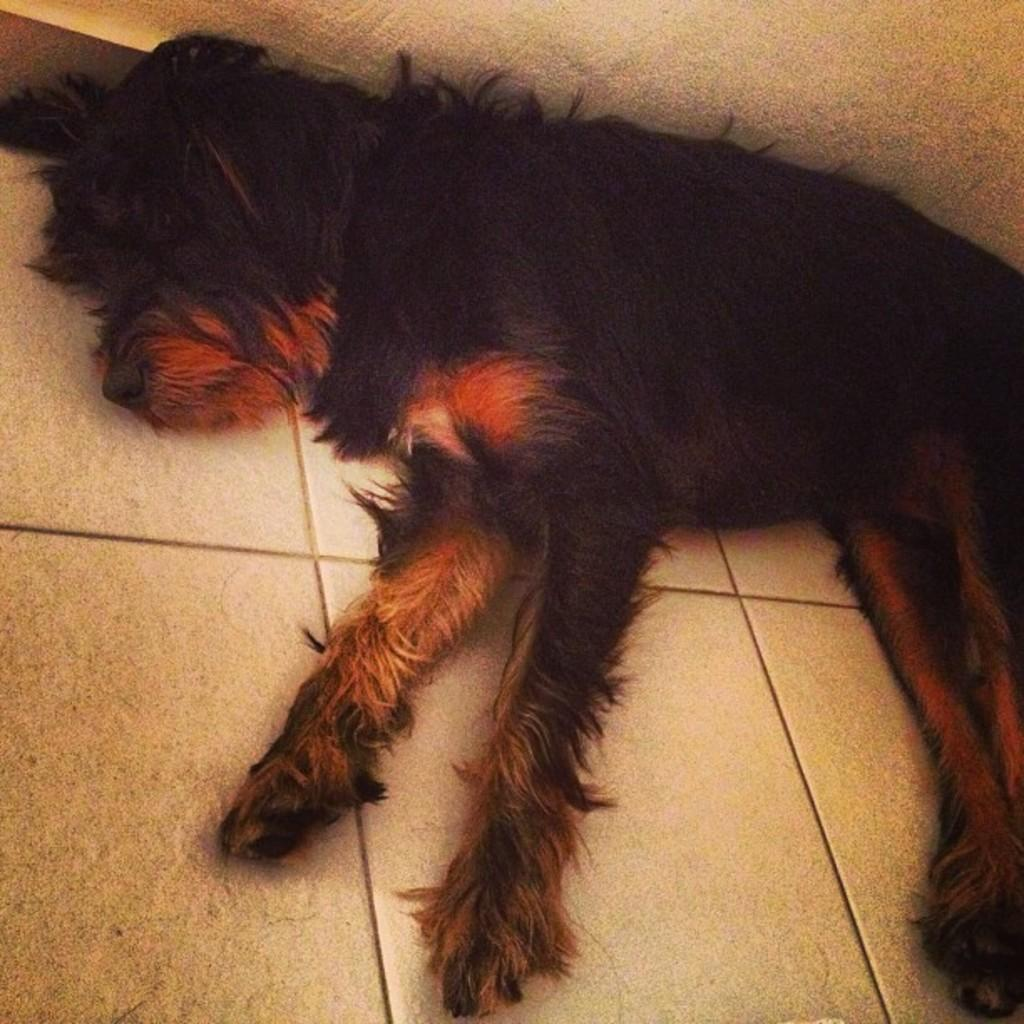What type of animal is present in the image? There is a dog in the image. What is the dog doing in the image? The dog is lying on the floor. What can be seen in the background of the image? There is a wall in the background of the image. What is the purpose of the net in the image? There is no net present in the image; it only features a dog lying on the floor and a wall in the background. 